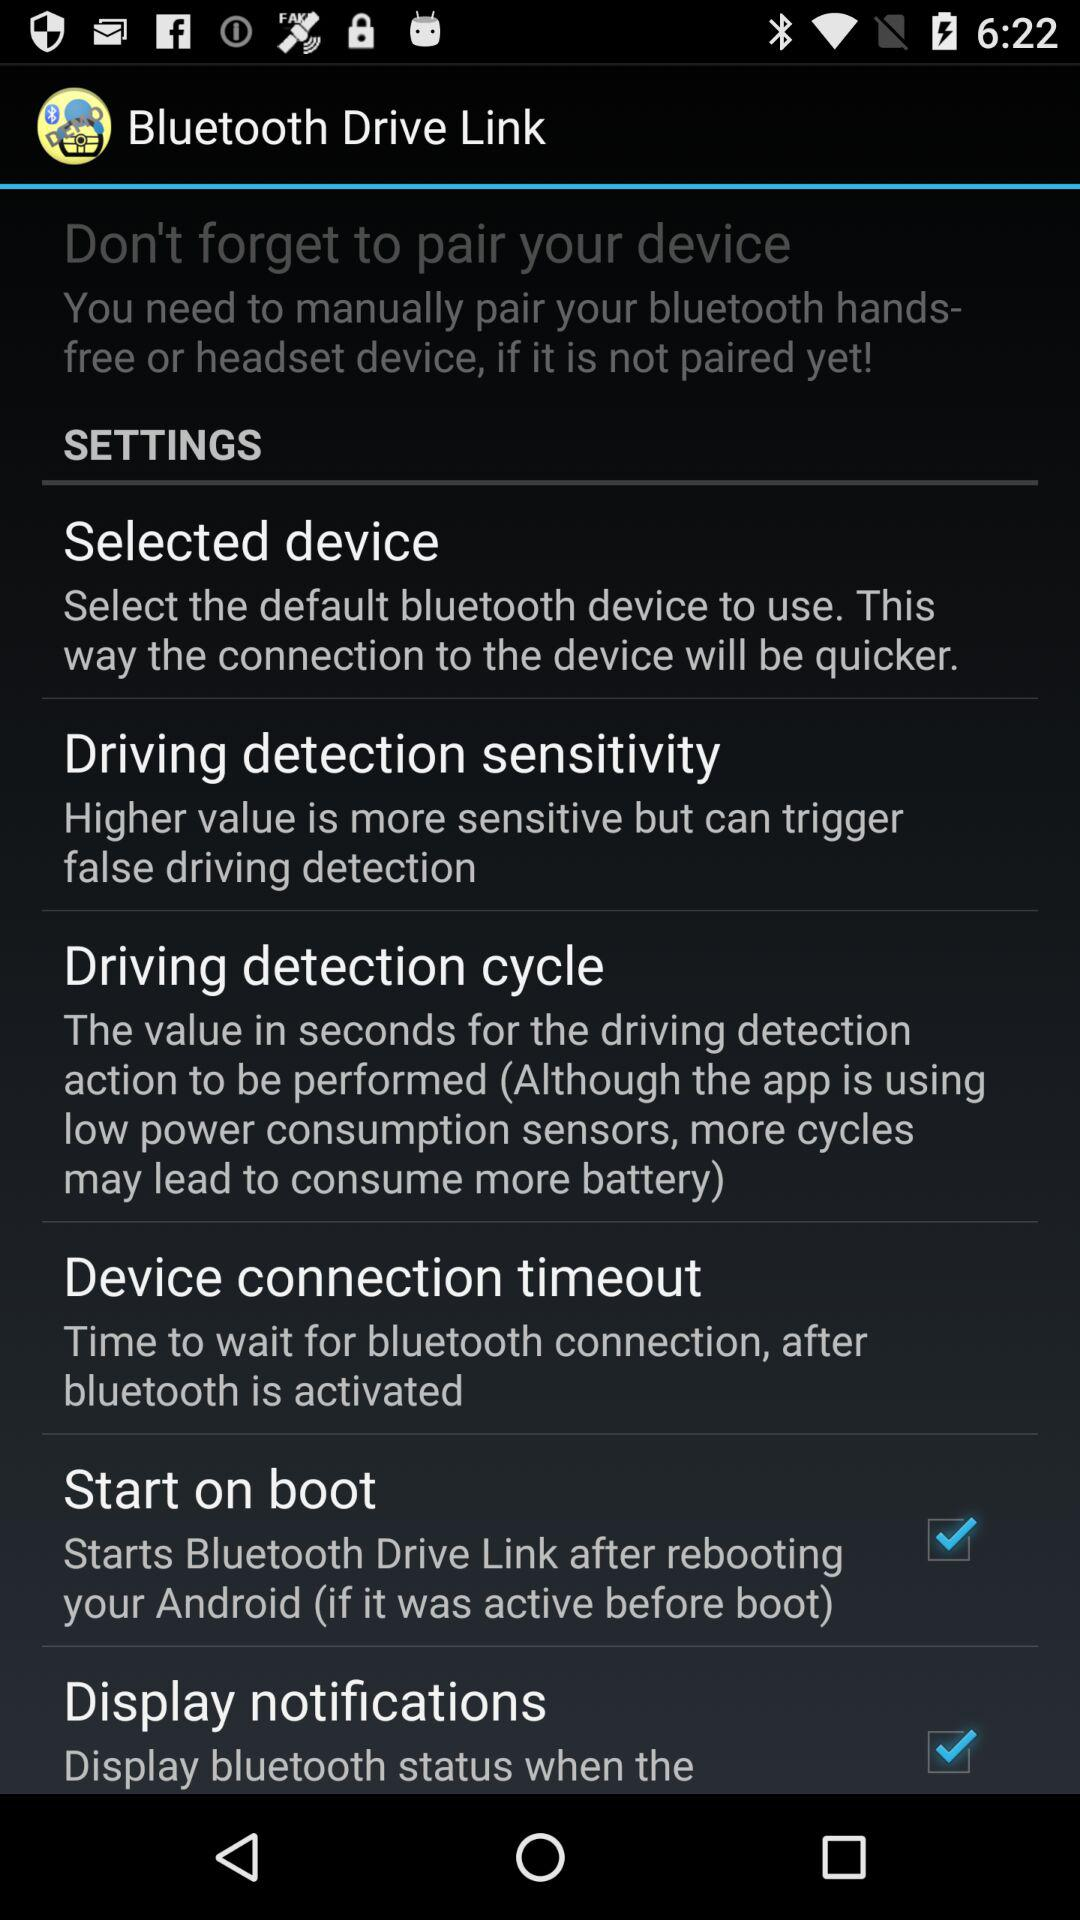What is the status of the "Display notifications"? The status is "on". 